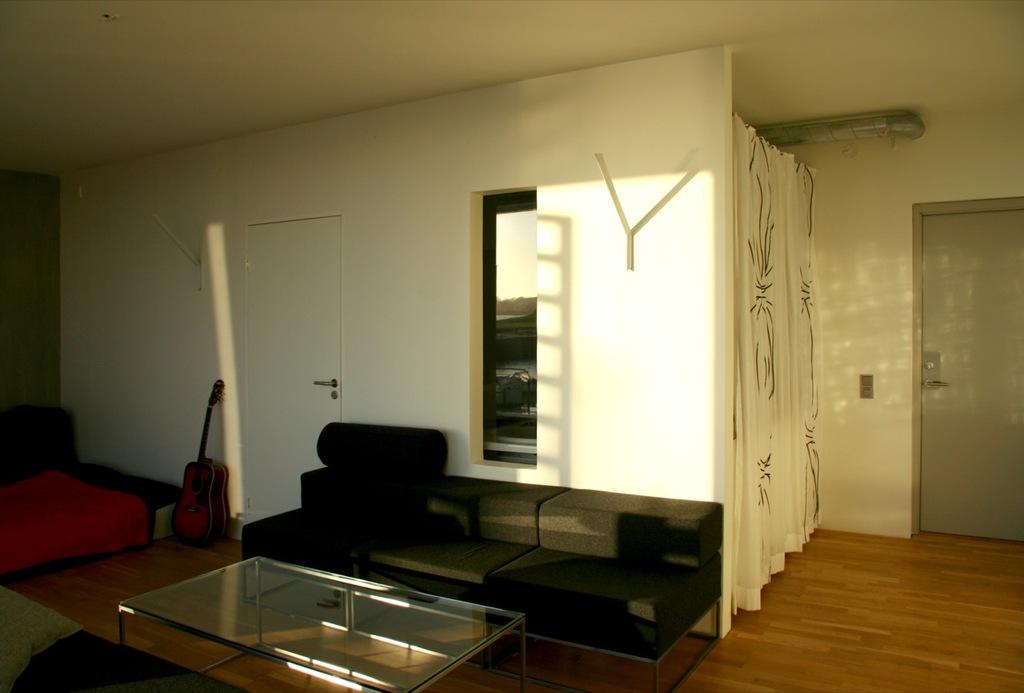What type of room is depicted in the image? The image is of a living room. What is one of the main features of a living room? There is a couch in the living room. What other furniture or objects can be seen in the living room? There is a table, a pillow, a carpet, a guitar, a pipe, and a curtain in the living room. What type of cord is used to play the ring on the head in the image? There is no cord, ring, or head present in the image. The image only features a living room with various furniture and objects. 